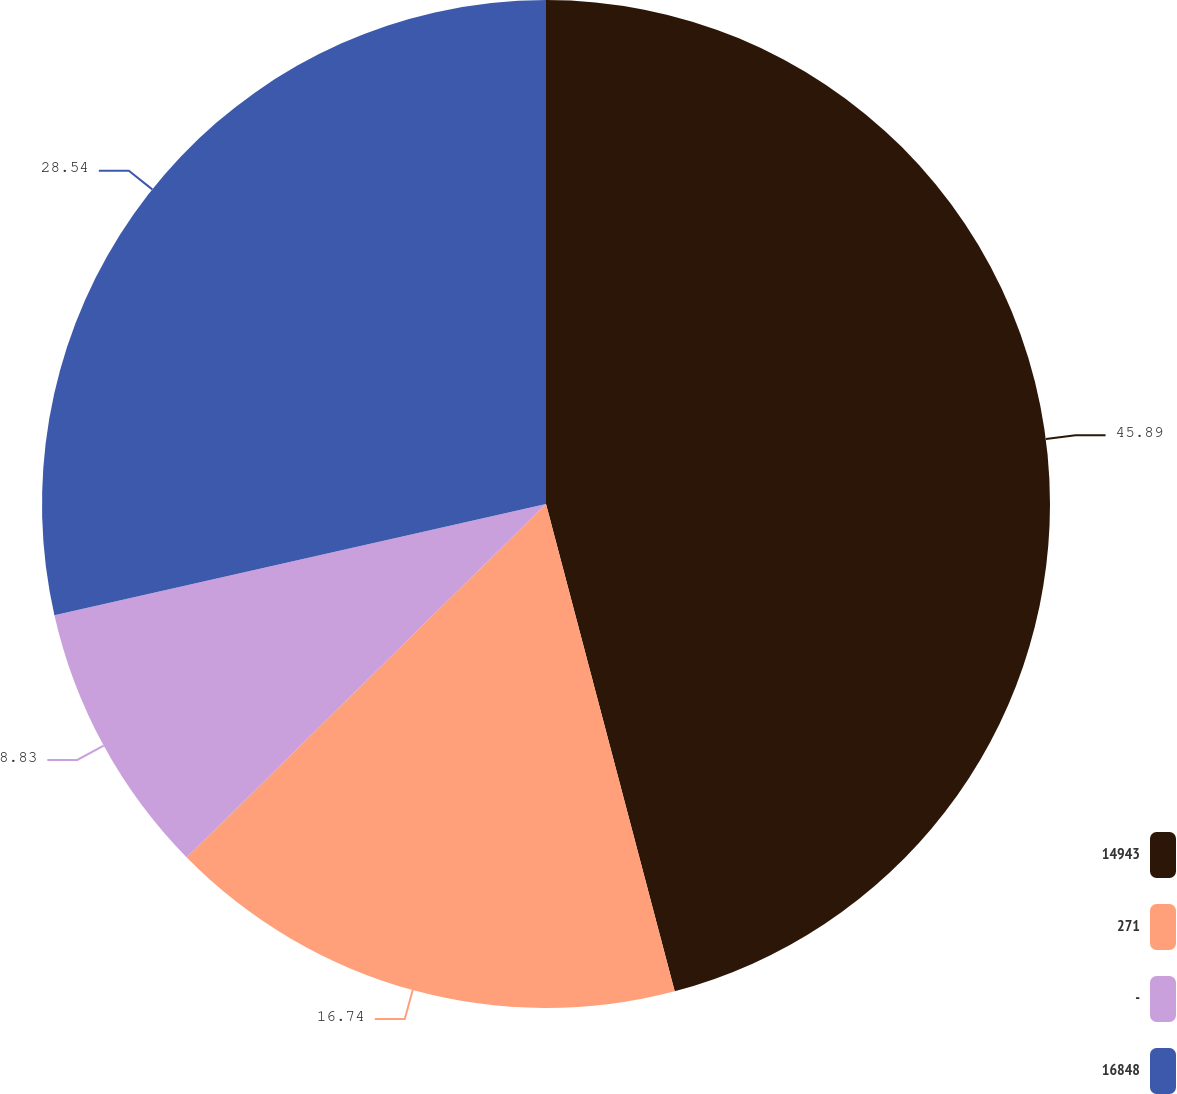Convert chart. <chart><loc_0><loc_0><loc_500><loc_500><pie_chart><fcel>14943<fcel>271<fcel>-<fcel>16848<nl><fcel>45.89%<fcel>16.74%<fcel>8.83%<fcel>28.54%<nl></chart> 